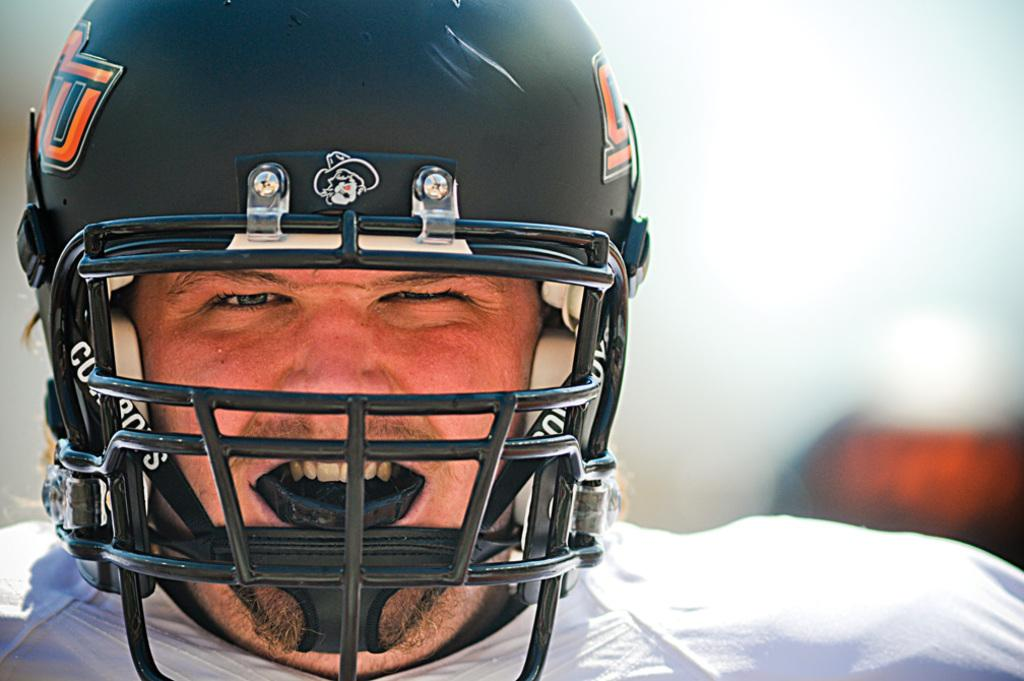What is the main subject of the image? There is a person in the image. What is the person wearing on their head? The person is wearing a helmet. Is there a board visible in the image? There is no board present in the image. Can you see a stream in the background of the image? There is no stream visible in the image. 